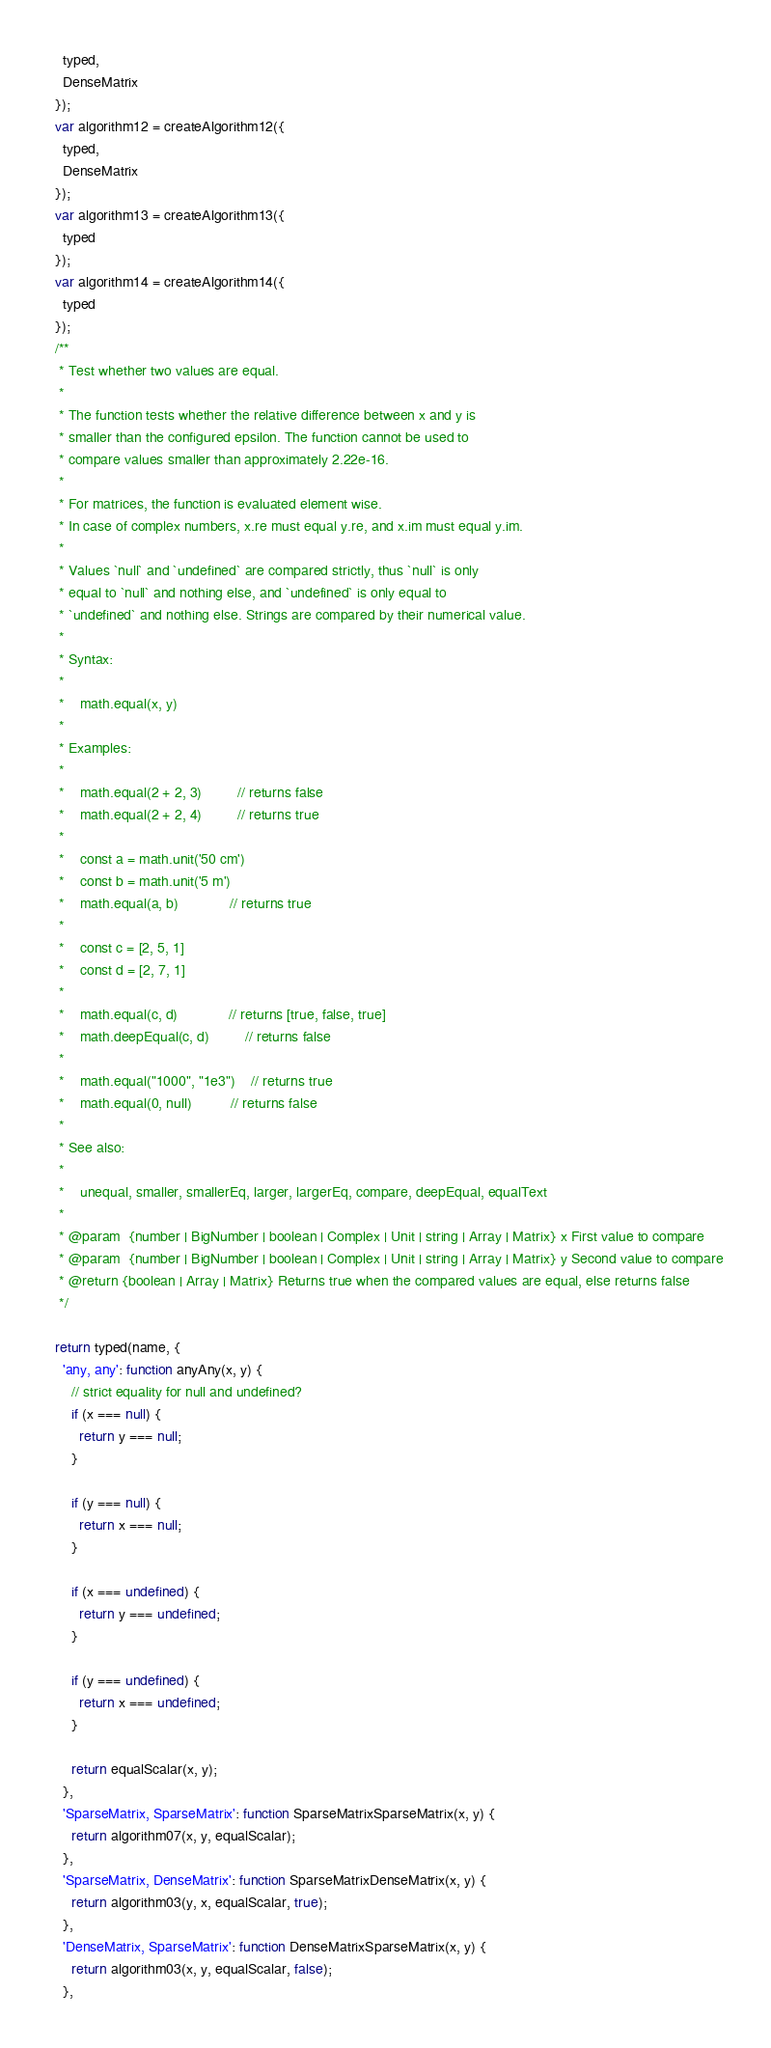Convert code to text. <code><loc_0><loc_0><loc_500><loc_500><_JavaScript_>    typed,
    DenseMatrix
  });
  var algorithm12 = createAlgorithm12({
    typed,
    DenseMatrix
  });
  var algorithm13 = createAlgorithm13({
    typed
  });
  var algorithm14 = createAlgorithm14({
    typed
  });
  /**
   * Test whether two values are equal.
   *
   * The function tests whether the relative difference between x and y is
   * smaller than the configured epsilon. The function cannot be used to
   * compare values smaller than approximately 2.22e-16.
   *
   * For matrices, the function is evaluated element wise.
   * In case of complex numbers, x.re must equal y.re, and x.im must equal y.im.
   *
   * Values `null` and `undefined` are compared strictly, thus `null` is only
   * equal to `null` and nothing else, and `undefined` is only equal to
   * `undefined` and nothing else. Strings are compared by their numerical value.
   *
   * Syntax:
   *
   *    math.equal(x, y)
   *
   * Examples:
   *
   *    math.equal(2 + 2, 3)         // returns false
   *    math.equal(2 + 2, 4)         // returns true
   *
   *    const a = math.unit('50 cm')
   *    const b = math.unit('5 m')
   *    math.equal(a, b)             // returns true
   *
   *    const c = [2, 5, 1]
   *    const d = [2, 7, 1]
   *
   *    math.equal(c, d)             // returns [true, false, true]
   *    math.deepEqual(c, d)         // returns false
   *
   *    math.equal("1000", "1e3")    // returns true
   *    math.equal(0, null)          // returns false
   *
   * See also:
   *
   *    unequal, smaller, smallerEq, larger, largerEq, compare, deepEqual, equalText
   *
   * @param  {number | BigNumber | boolean | Complex | Unit | string | Array | Matrix} x First value to compare
   * @param  {number | BigNumber | boolean | Complex | Unit | string | Array | Matrix} y Second value to compare
   * @return {boolean | Array | Matrix} Returns true when the compared values are equal, else returns false
   */

  return typed(name, {
    'any, any': function anyAny(x, y) {
      // strict equality for null and undefined?
      if (x === null) {
        return y === null;
      }

      if (y === null) {
        return x === null;
      }

      if (x === undefined) {
        return y === undefined;
      }

      if (y === undefined) {
        return x === undefined;
      }

      return equalScalar(x, y);
    },
    'SparseMatrix, SparseMatrix': function SparseMatrixSparseMatrix(x, y) {
      return algorithm07(x, y, equalScalar);
    },
    'SparseMatrix, DenseMatrix': function SparseMatrixDenseMatrix(x, y) {
      return algorithm03(y, x, equalScalar, true);
    },
    'DenseMatrix, SparseMatrix': function DenseMatrixSparseMatrix(x, y) {
      return algorithm03(x, y, equalScalar, false);
    },</code> 